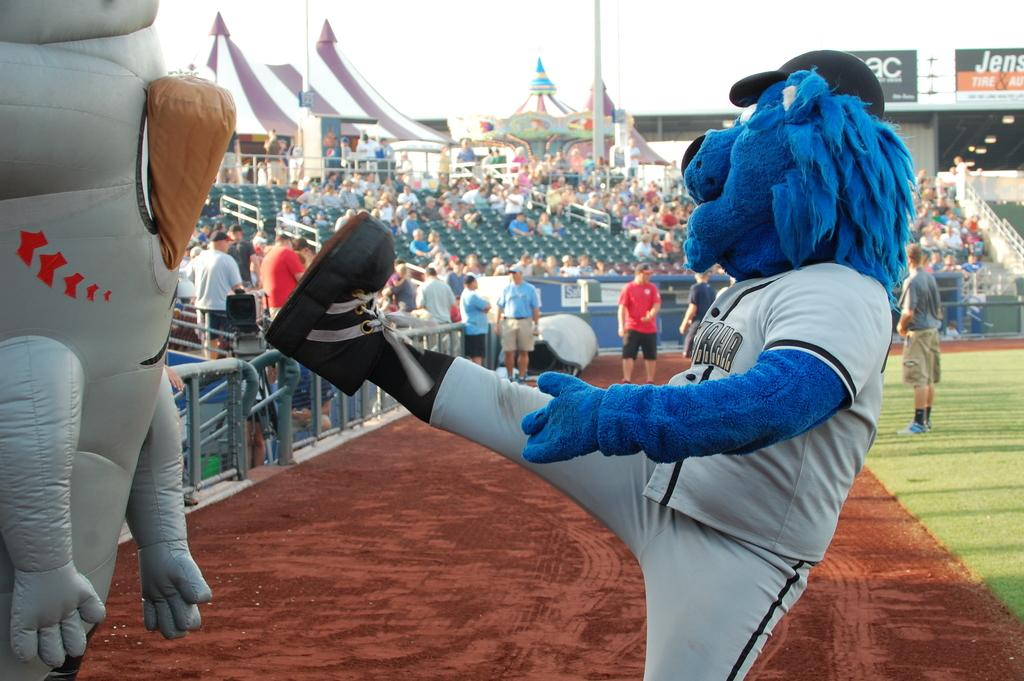Provide a one-sentence caption for the provided image. The letters a and c can be seen on a sign at a baseball diamond. 